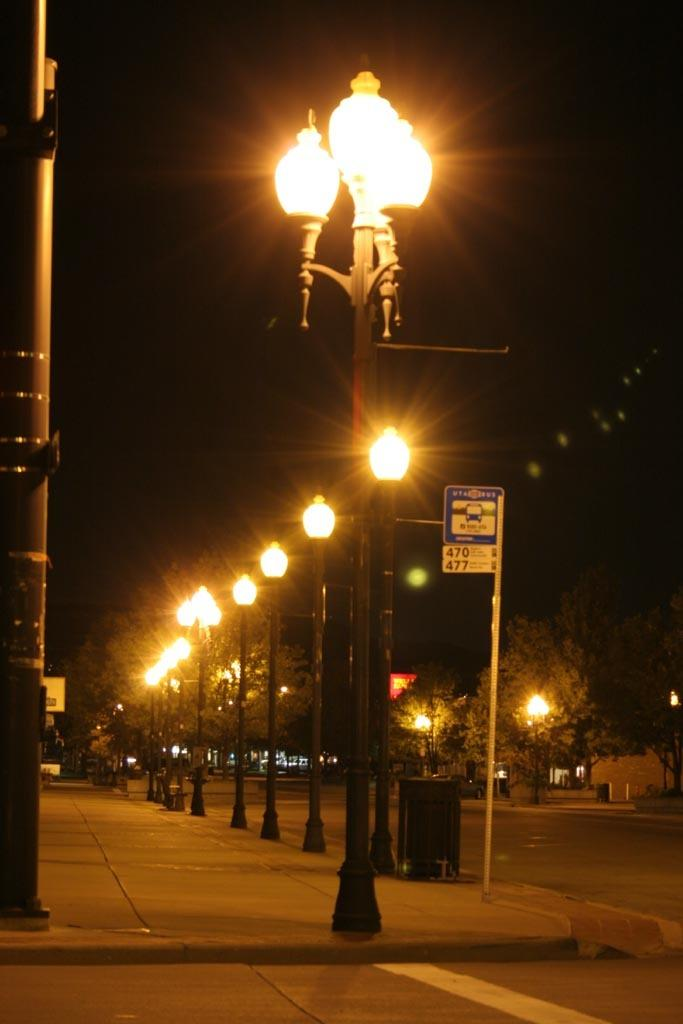What type of natural elements can be seen in the image? There are trees in the image. What man-made objects are present in the image? There are poles with lights in the image. What can be seen in the background of the image? The sky is visible in the background of the image. Can you describe the house in the image? There is no house present in the image; it features trees and poles with lights. What type of bun is being used to fight in the image? There is no fight or bun present in the image. 